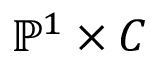Convert formula to latex. <formula><loc_0><loc_0><loc_500><loc_500>\mathbb { P } ^ { 1 } \times C</formula> 